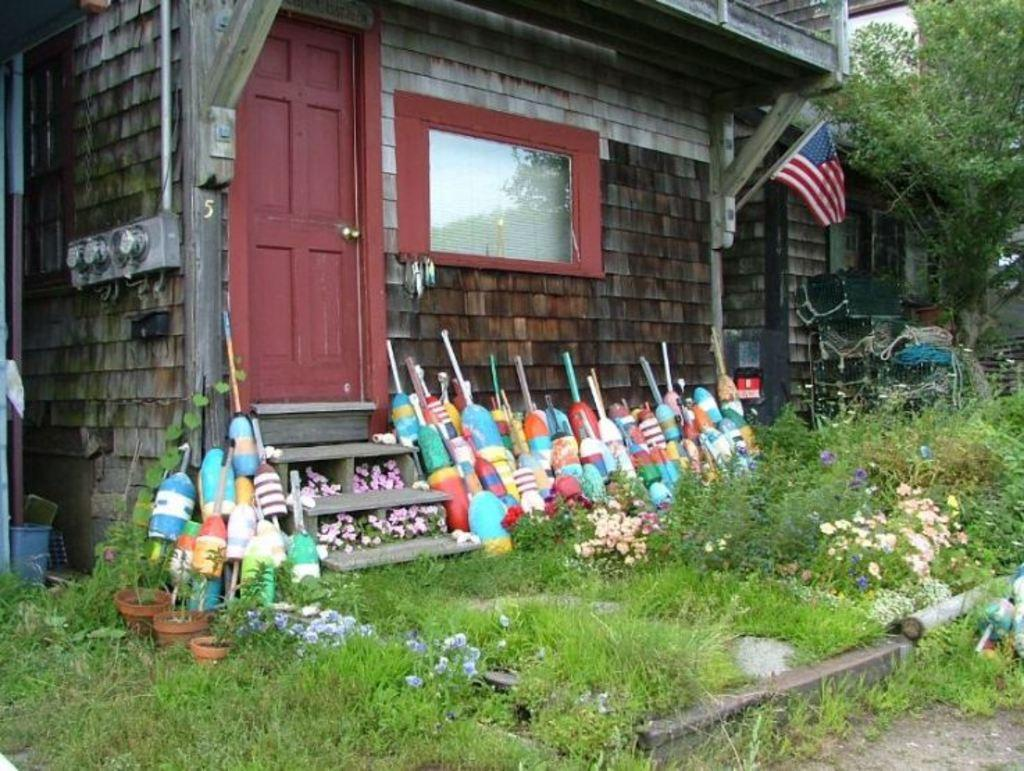What type of structures can be seen in the image? There are buildings in the image. What type of vegetation is present in the image? There are plants, flowers, and trees in the image. What type of containers are used for the flowers? There are flower pots in the image. What type of symbol is visible in the image? There is a flag in the image. What type of openings are present in the buildings? There are doors and windows in the image. What type of objects can be seen in the image? There are objects in the image. What flavor of robin can be seen in the image? There are no robins present in the image. What type of zipper is used on the door in the image? There is no mention of a zipper on the door in the image; it is a regular door with a handle. 